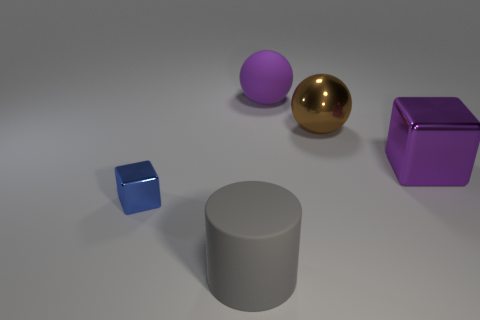How many matte spheres have the same color as the big metallic block?
Offer a terse response. 1. There is a blue cube; is its size the same as the purple object that is to the right of the purple rubber sphere?
Provide a succinct answer. No. There is a metal block right of the rubber thing that is in front of the purple thing behind the purple shiny block; what is its size?
Your answer should be very brief. Large. What number of large objects are on the left side of the tiny shiny object?
Make the answer very short. 0. What is the material of the cylinder in front of the purple object behind the metallic ball?
Your answer should be compact. Rubber. Are there any other things that are the same size as the blue object?
Make the answer very short. No. Does the cylinder have the same size as the brown sphere?
Make the answer very short. Yes. What number of things are either metal blocks that are left of the big purple metal block or large things that are behind the big purple block?
Offer a very short reply. 3. Are there more matte things to the right of the purple block than purple matte things?
Keep it short and to the point. No. How many other things are there of the same shape as the brown thing?
Your answer should be compact. 1. 